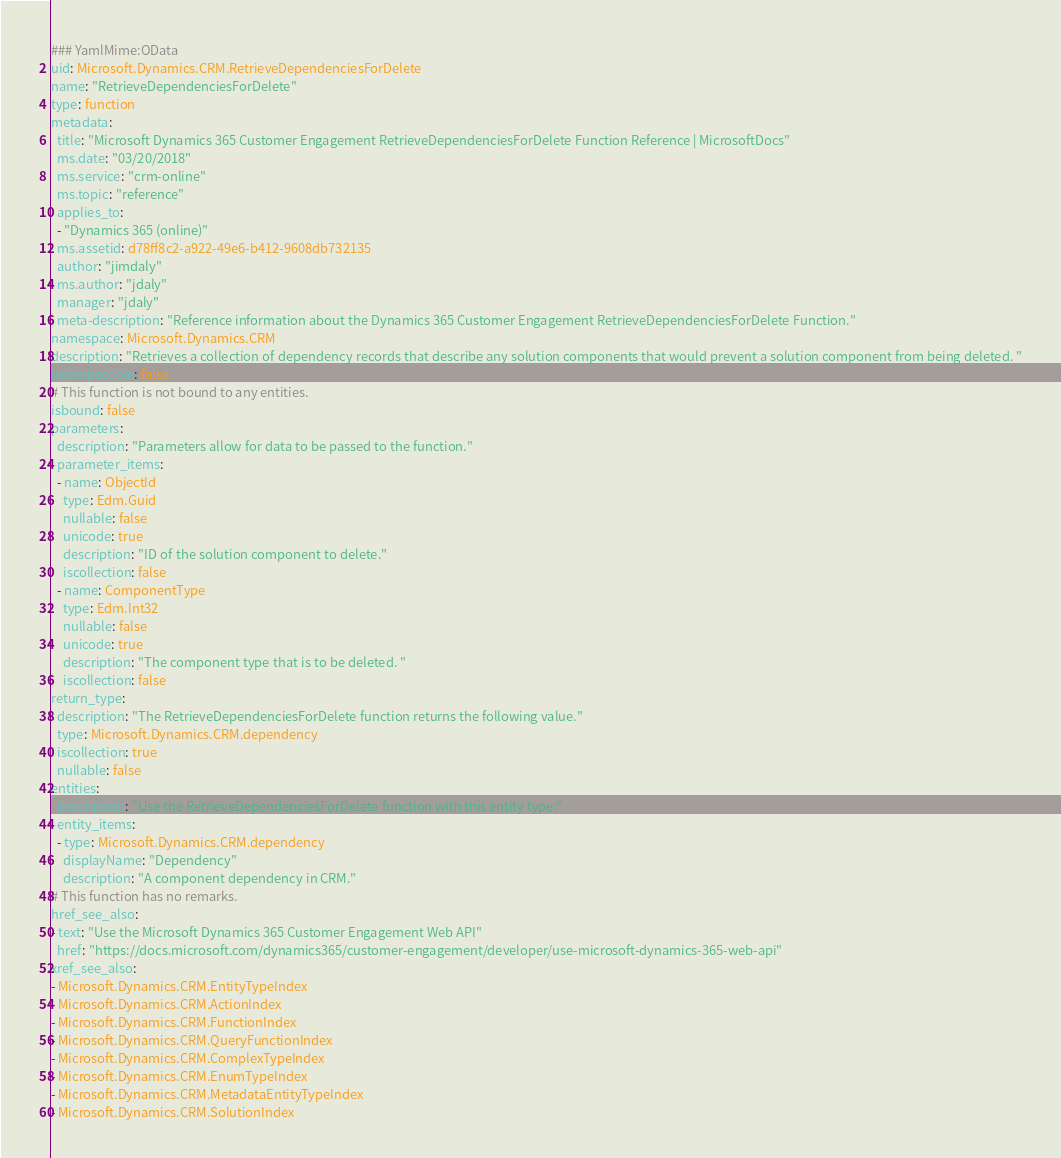<code> <loc_0><loc_0><loc_500><loc_500><_YAML_>### YamlMime:OData
uid: Microsoft.Dynamics.CRM.RetrieveDependenciesForDelete
name: "RetrieveDependenciesForDelete"
type: function
metadata: 
  title: "Microsoft Dynamics 365 Customer Engagement RetrieveDependenciesForDelete Function Reference | MicrosoftDocs"
  ms.date: "03/20/2018"
  ms.service: "crm-online"
  ms.topic: "reference"
  applies_to: 
  - "Dynamics 365 (online)"
  ms.assetid: d78ff8c2-a922-49e6-b412-9608db732135
  author: "jimdaly"
  ms.author: "jdaly"
  manager: "jdaly"
  meta-description: "Reference information about the Dynamics 365 Customer Engagement RetrieveDependenciesForDelete Function."
namespace: Microsoft.Dynamics.CRM
description: "Retrieves a collection of dependency records that describe any solution components that would prevent a solution component from being deleted. "
iscomposable: false
# This function is not bound to any entities.
isbound: false
parameters:
  description: "Parameters allow for data to be passed to the function."
  parameter_items:
  - name: ObjectId
    type: Edm.Guid
    nullable: false
    unicode: true
    description: "ID of the solution component to delete."
    iscollection: false
  - name: ComponentType
    type: Edm.Int32
    nullable: false
    unicode: true
    description: "The component type that is to be deleted. "
    iscollection: false
return_type:
  description: "The RetrieveDependenciesForDelete function returns the following value."
  type: Microsoft.Dynamics.CRM.dependency
  iscollection: true
  nullable: false
entities:
  description: "Use the RetrieveDependenciesForDelete function with this entity type:"
  entity_items:
  - type: Microsoft.Dynamics.CRM.dependency
    displayName: "Dependency"
    description: "A component dependency in CRM."
# This function has no remarks.
href_see_also:
- text: "Use the Microsoft Dynamics 365 Customer Engagement Web API"
  href: "https://docs.microsoft.com/dynamics365/customer-engagement/developer/use-microsoft-dynamics-365-web-api"
xref_see_also:
- Microsoft.Dynamics.CRM.EntityTypeIndex
- Microsoft.Dynamics.CRM.ActionIndex
- Microsoft.Dynamics.CRM.FunctionIndex
- Microsoft.Dynamics.CRM.QueryFunctionIndex
- Microsoft.Dynamics.CRM.ComplexTypeIndex
- Microsoft.Dynamics.CRM.EnumTypeIndex
- Microsoft.Dynamics.CRM.MetadataEntityTypeIndex
- Microsoft.Dynamics.CRM.SolutionIndex</code> 